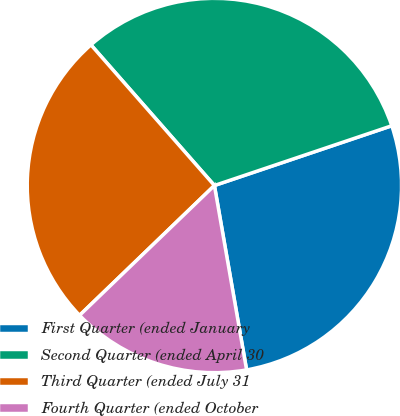<chart> <loc_0><loc_0><loc_500><loc_500><pie_chart><fcel>First Quarter (ended January<fcel>Second Quarter (ended April 30<fcel>Third Quarter (ended July 31<fcel>Fourth Quarter (ended October<nl><fcel>27.42%<fcel>31.29%<fcel>25.73%<fcel>15.55%<nl></chart> 